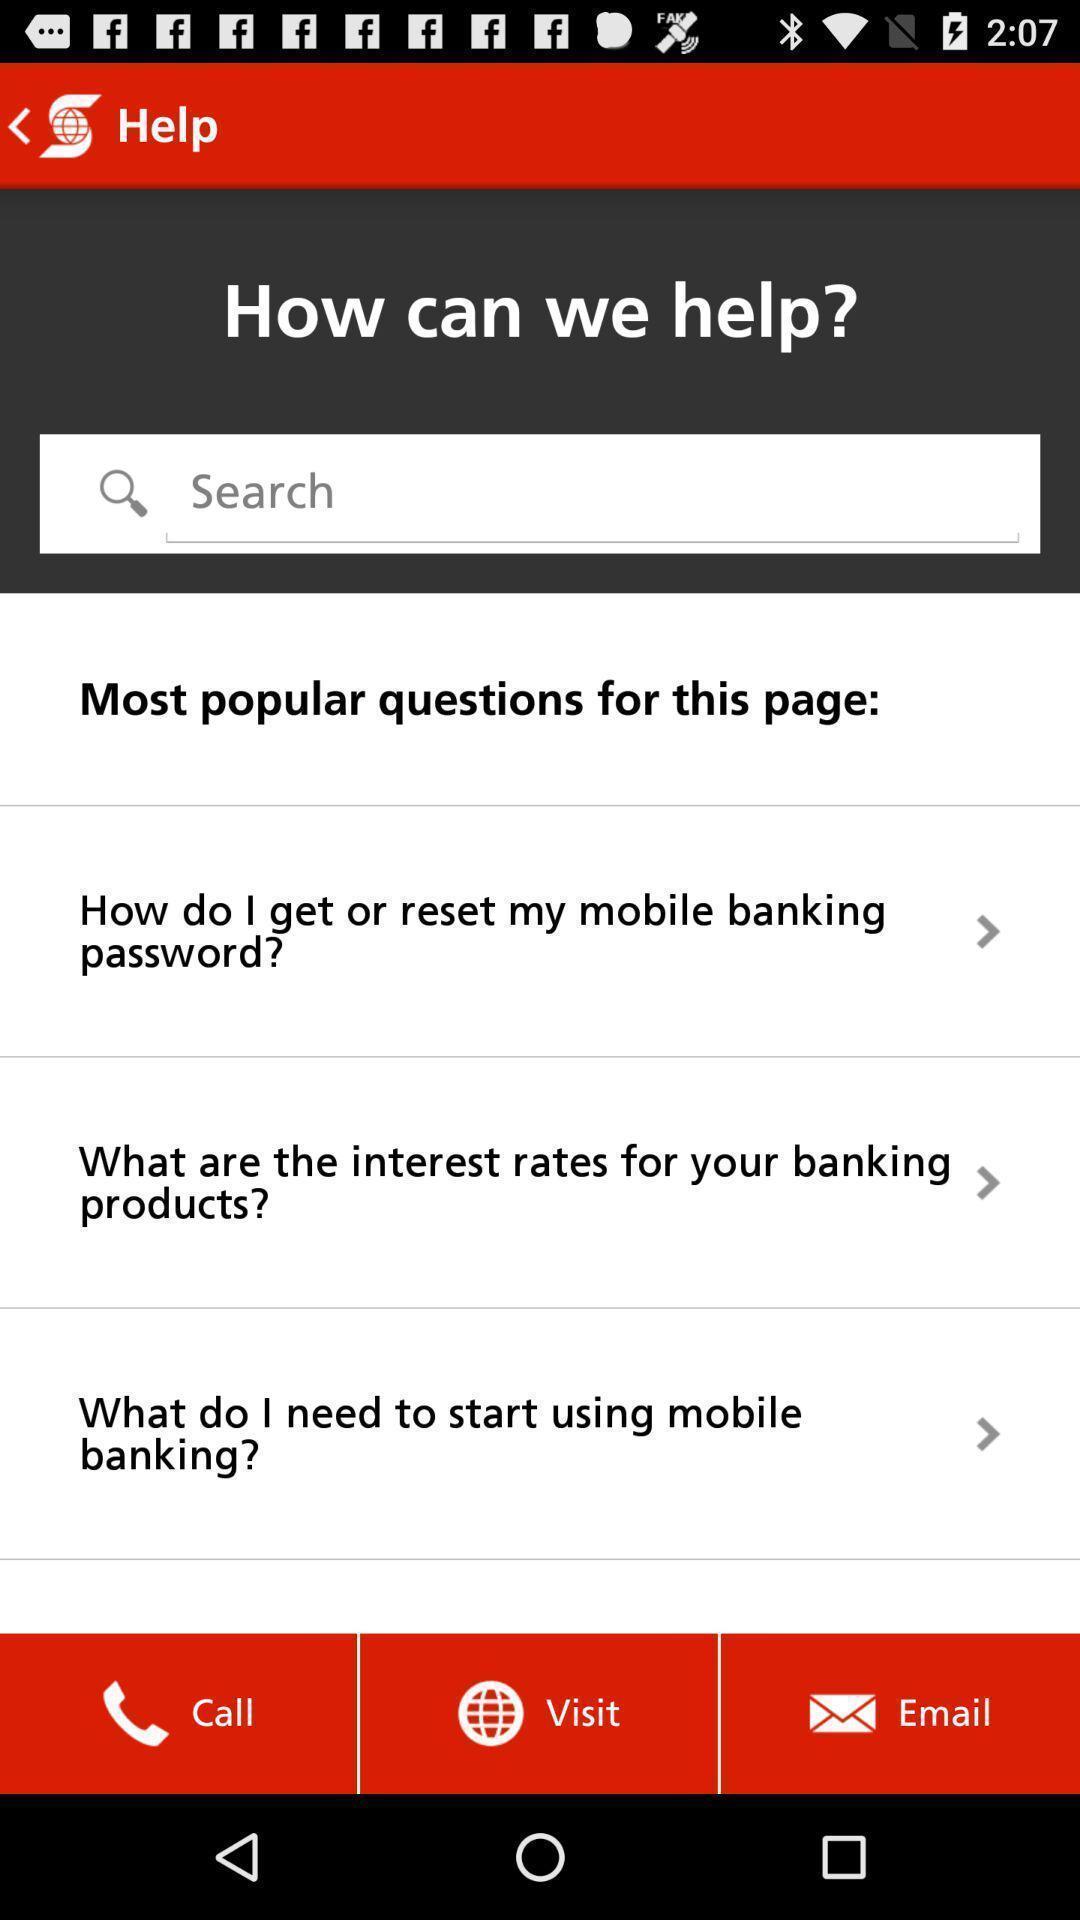Tell me what you see in this picture. Screen displaying the options options in help tab. 